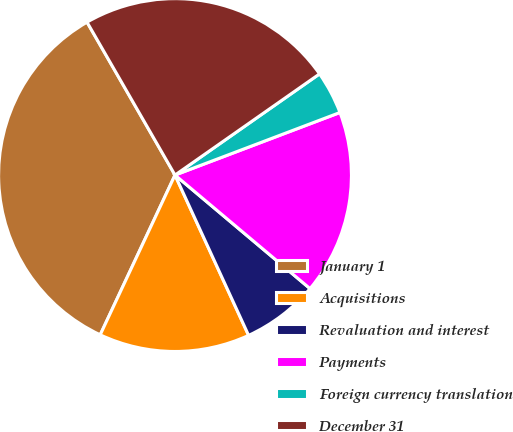Convert chart to OTSL. <chart><loc_0><loc_0><loc_500><loc_500><pie_chart><fcel>January 1<fcel>Acquisitions<fcel>Revaluation and interest<fcel>Payments<fcel>Foreign currency translation<fcel>December 31<nl><fcel>34.72%<fcel>13.82%<fcel>7.02%<fcel>16.9%<fcel>3.95%<fcel>23.59%<nl></chart> 